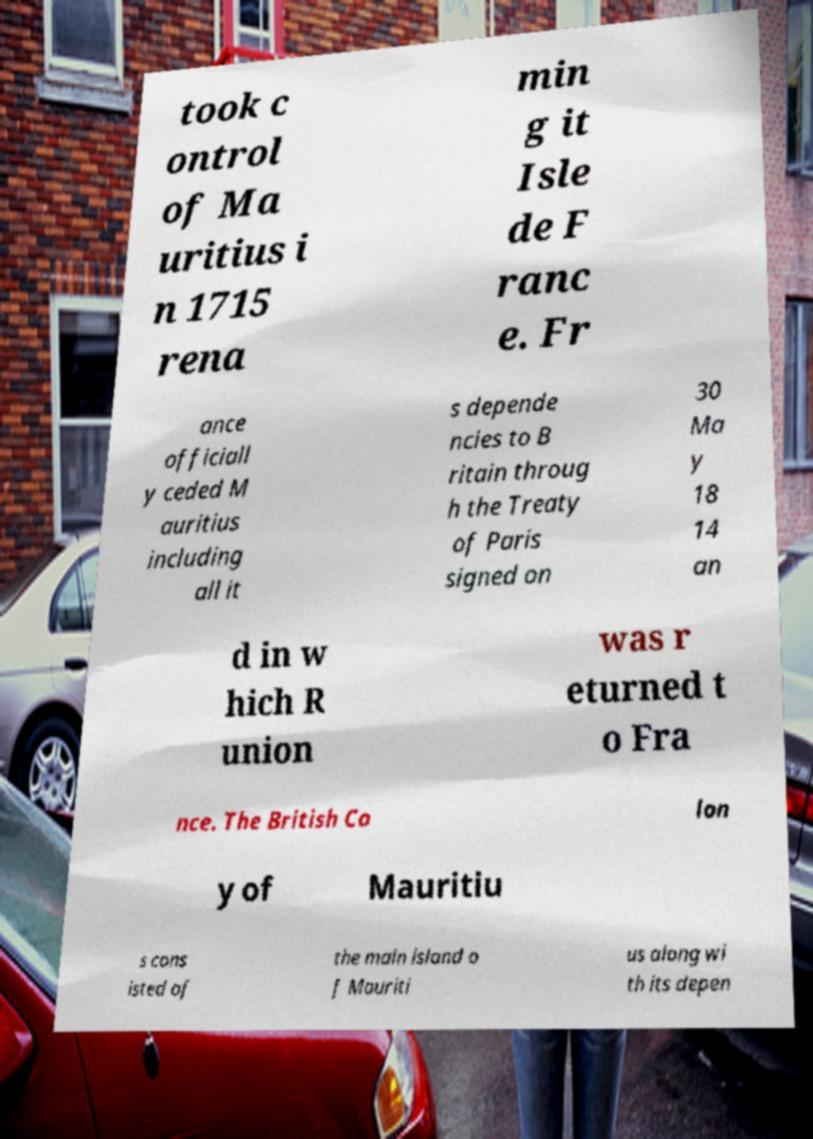Can you read and provide the text displayed in the image?This photo seems to have some interesting text. Can you extract and type it out for me? took c ontrol of Ma uritius i n 1715 rena min g it Isle de F ranc e. Fr ance officiall y ceded M auritius including all it s depende ncies to B ritain throug h the Treaty of Paris signed on 30 Ma y 18 14 an d in w hich R union was r eturned t o Fra nce. The British Co lon y of Mauritiu s cons isted of the main island o f Mauriti us along wi th its depen 